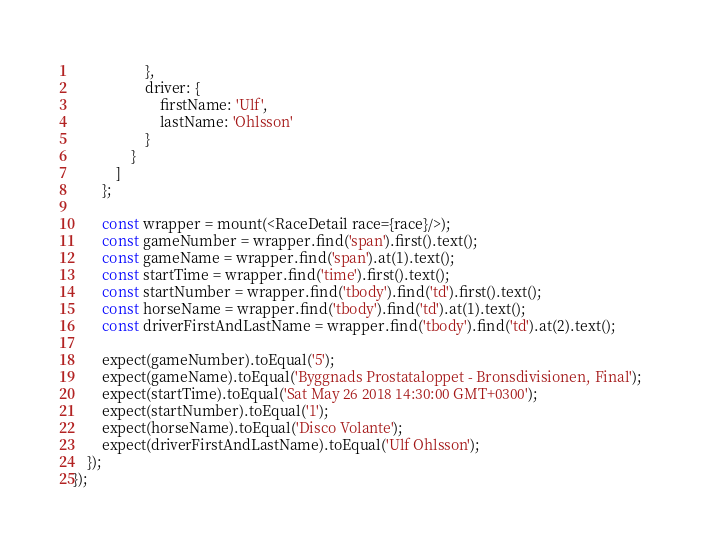<code> <loc_0><loc_0><loc_500><loc_500><_JavaScript_>                    },
                    driver: {
                        firstName: 'Ulf',
                        lastName: 'Ohlsson'
                    }
                }
            ]
        };

        const wrapper = mount(<RaceDetail race={race}/>);
        const gameNumber = wrapper.find('span').first().text();
        const gameName = wrapper.find('span').at(1).text();
        const startTime = wrapper.find('time').first().text();
        const startNumber = wrapper.find('tbody').find('td').first().text();
        const horseName = wrapper.find('tbody').find('td').at(1).text();
        const driverFirstAndLastName = wrapper.find('tbody').find('td').at(2).text();

        expect(gameNumber).toEqual('5');
        expect(gameName).toEqual('Byggnads Prostataloppet - Bronsdivisionen, Final');
        expect(startTime).toEqual('Sat May 26 2018 14:30:00 GMT+0300');
        expect(startNumber).toEqual('1');
        expect(horseName).toEqual('Disco Volante');
        expect(driverFirstAndLastName).toEqual('Ulf Ohlsson');
    });
});</code> 